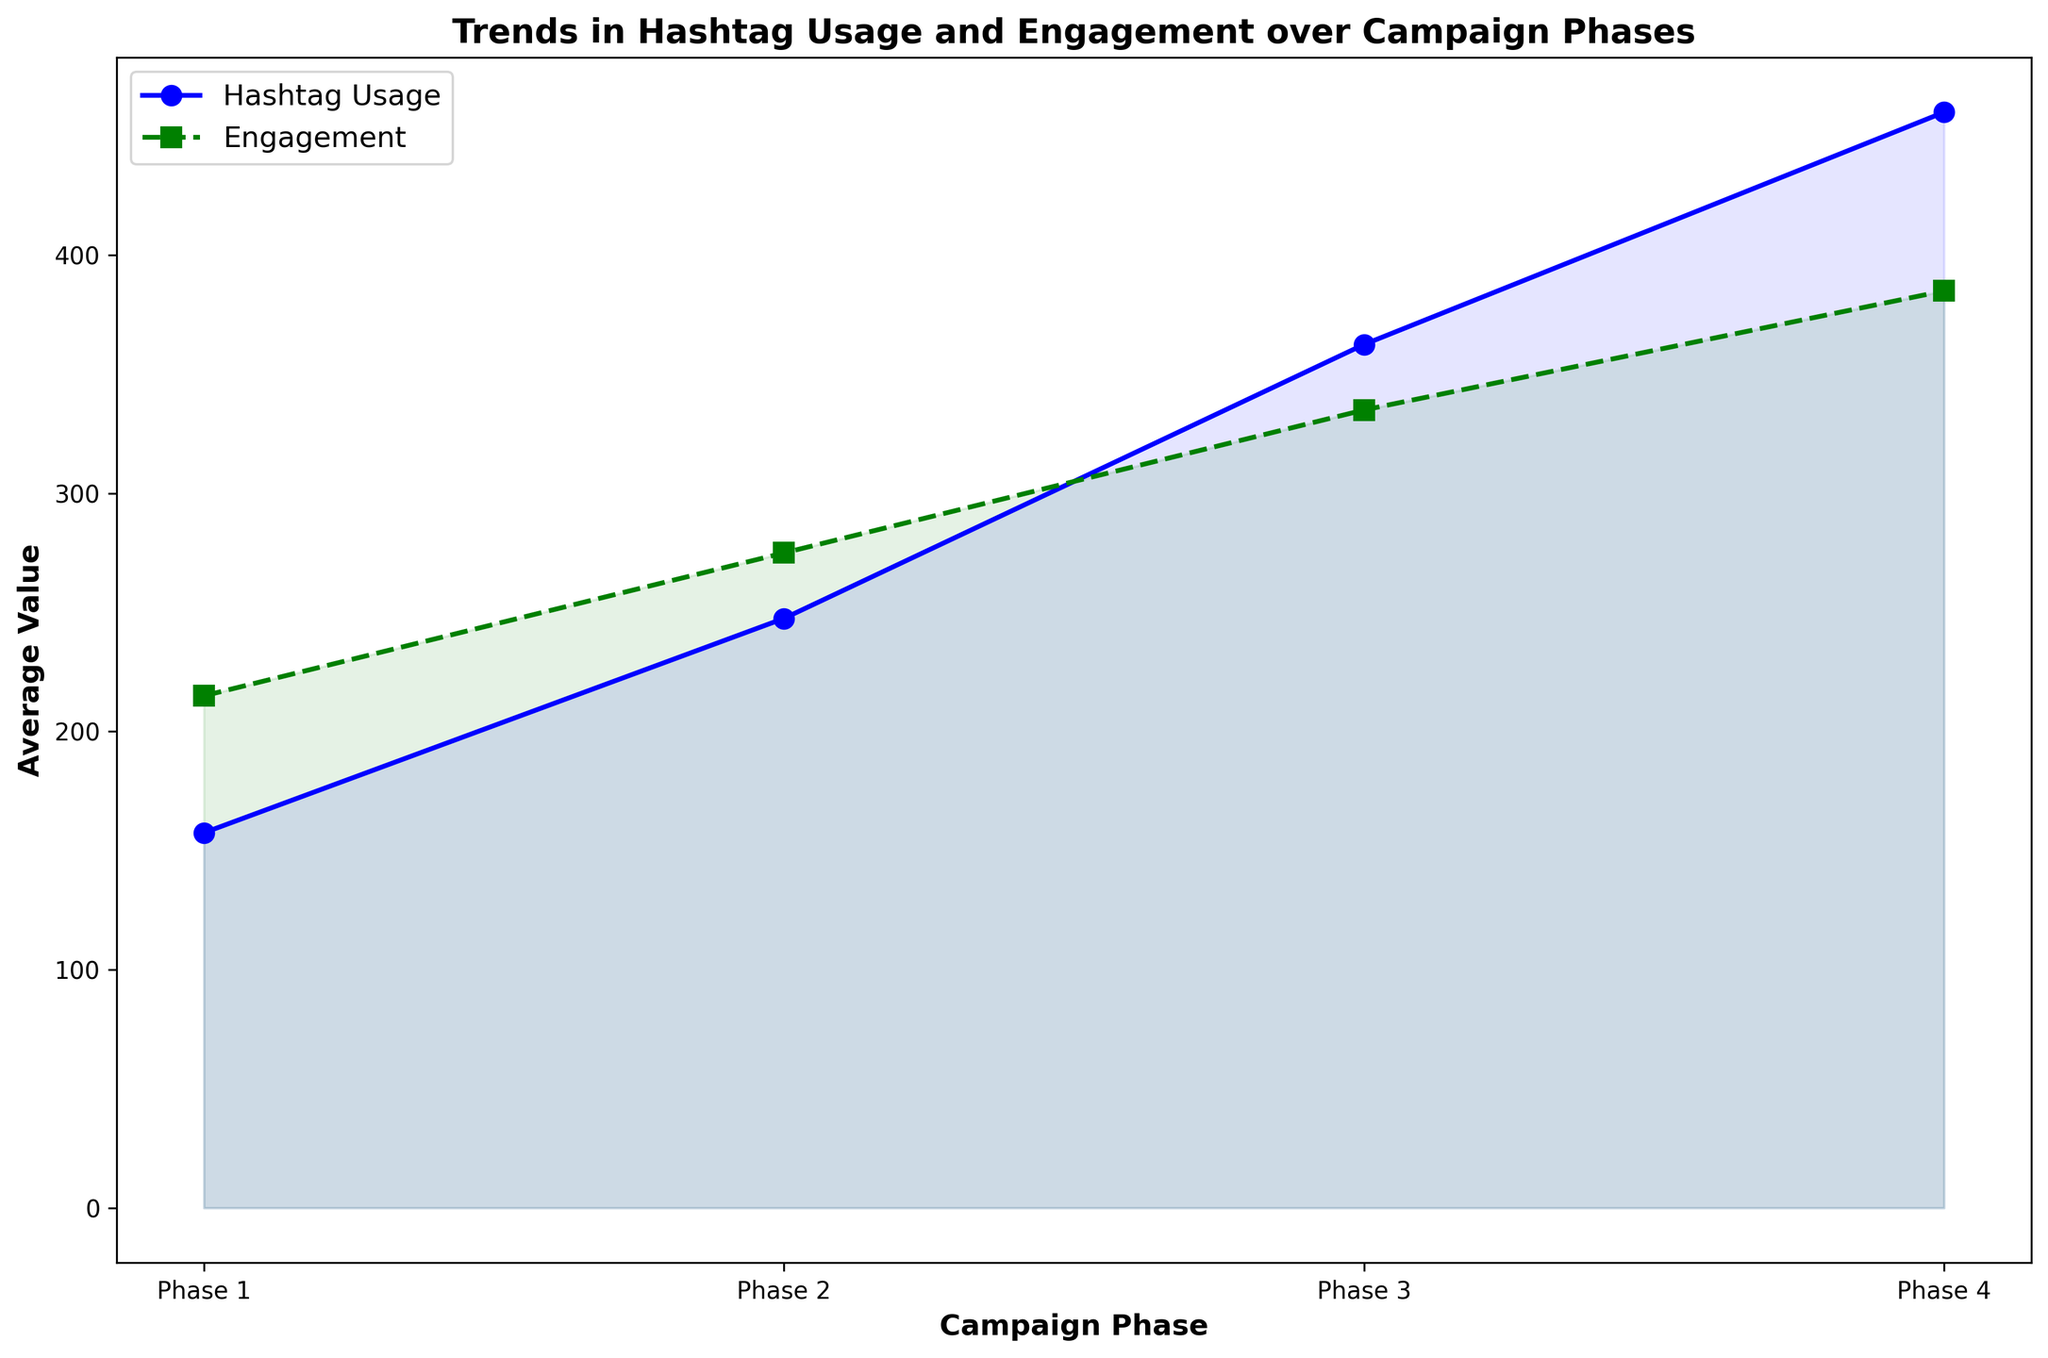What happens to the average hashtag usage from Phase 1 to Phase 2? By examining the blue "Hashtag Usage" line, we see it rises from Phase 1 to Phase 2.
Answer: Increases How does the engagement in Phase 3 compare to Phase 2? The green "Engagement" line shows that the engagement level is higher in Phase 3 than in Phase 2.
Answer: Higher Which phase has the highest average engagement? The green "Engagement" line peaks at Phase 4, indicating it has the highest average engagement.
Answer: Phase 4 Is there a phase where hashtag usage and engagement are both increasing compared to the previous phase? Both "Hashtag Usage" (blue) and "Engagement" (green) lines show an overall increasing trend from Phase 3 to Phase 4.
Answer: Yes, Phase 4 Between which two phases is the increase in average hashtag usage most significant? The steepest rise in the blue "Hashtag Usage" line occurs between Phase 2 and Phase 3.
Answer: Phase 2 to Phase 3 By how much does the average engagement increase from Phase 1 to Phase 4? Engagement in Phase 1 averages around 215, and in Phase 4, it averages around 385. The difference is 385 - 215.
Answer: 170 What is the average hashtag usage in Phase 3? The blue line for Phase 3 is around the midpoint value indicated on the y-axis, which is near 362.5.
Answer: 362.5 Compare the general trend of hashtag usage and engagement across the phases. Both hashtag usage and engagement generally increase across the phases, but the hashtag usage line shows a more pronounced increase.
Answer: Both increase, more pronounced for hashtag usage Are there any phases where engagement decreases? No segments of the green "Engagement" line show a decrease; it either increases or stays constant.
Answer: No What is the difference between hashtag usage and engagement in Phase 4? The average hashtag usage in Phase 4 is around 460, and the engagement is about 385. The difference is 460 - 385.
Answer: 75 